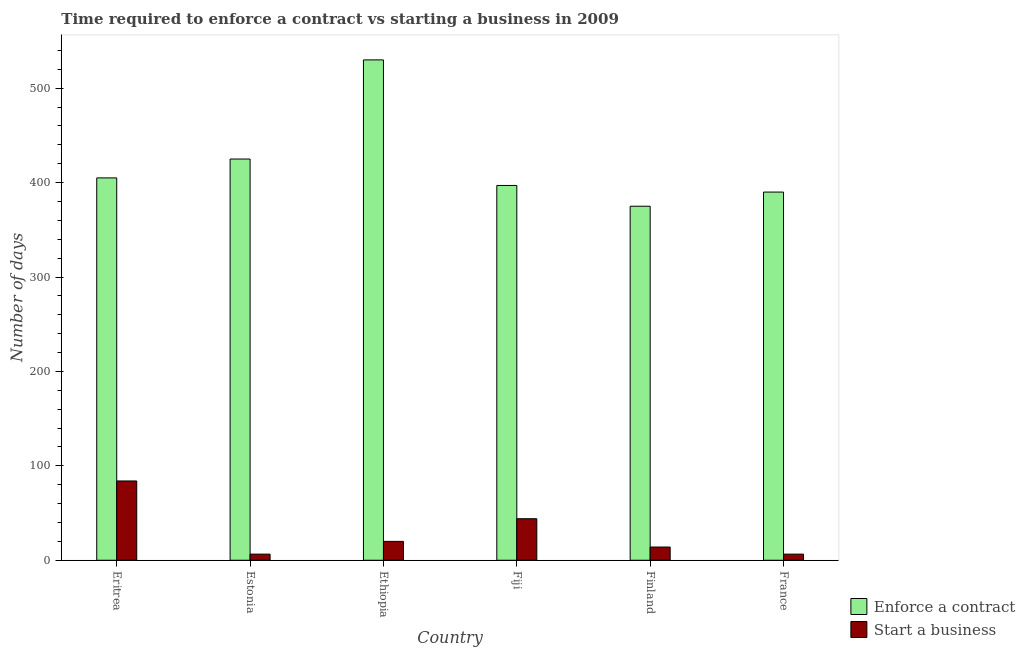How many groups of bars are there?
Provide a short and direct response. 6. Are the number of bars per tick equal to the number of legend labels?
Your answer should be very brief. Yes. Are the number of bars on each tick of the X-axis equal?
Provide a short and direct response. Yes. How many bars are there on the 6th tick from the left?
Your response must be concise. 2. How many bars are there on the 1st tick from the right?
Provide a short and direct response. 2. What is the label of the 4th group of bars from the left?
Give a very brief answer. Fiji. What is the number of days to enforece a contract in Ethiopia?
Provide a short and direct response. 530. Across all countries, what is the maximum number of days to enforece a contract?
Offer a terse response. 530. In which country was the number of days to enforece a contract maximum?
Your response must be concise. Ethiopia. In which country was the number of days to start a business minimum?
Offer a terse response. Estonia. What is the total number of days to enforece a contract in the graph?
Your response must be concise. 2522. What is the difference between the number of days to start a business in Fiji and the number of days to enforece a contract in Estonia?
Offer a very short reply. -381. What is the average number of days to enforece a contract per country?
Make the answer very short. 420.33. What is the difference between the number of days to enforece a contract and number of days to start a business in Ethiopia?
Your answer should be very brief. 510. In how many countries, is the number of days to start a business greater than 260 days?
Your answer should be compact. 0. What is the ratio of the number of days to enforece a contract in Fiji to that in Finland?
Ensure brevity in your answer.  1.06. Is the difference between the number of days to enforece a contract in Ethiopia and Finland greater than the difference between the number of days to start a business in Ethiopia and Finland?
Provide a succinct answer. Yes. What is the difference between the highest and the second highest number of days to start a business?
Offer a very short reply. 40. What is the difference between the highest and the lowest number of days to enforece a contract?
Ensure brevity in your answer.  155. In how many countries, is the number of days to enforece a contract greater than the average number of days to enforece a contract taken over all countries?
Keep it short and to the point. 2. Is the sum of the number of days to start a business in Eritrea and Estonia greater than the maximum number of days to enforece a contract across all countries?
Offer a very short reply. No. What does the 2nd bar from the left in Fiji represents?
Give a very brief answer. Start a business. What does the 2nd bar from the right in Fiji represents?
Provide a succinct answer. Enforce a contract. How many bars are there?
Ensure brevity in your answer.  12. What is the difference between two consecutive major ticks on the Y-axis?
Keep it short and to the point. 100. Are the values on the major ticks of Y-axis written in scientific E-notation?
Provide a succinct answer. No. Does the graph contain grids?
Provide a succinct answer. No. How many legend labels are there?
Your answer should be very brief. 2. What is the title of the graph?
Keep it short and to the point. Time required to enforce a contract vs starting a business in 2009. What is the label or title of the X-axis?
Give a very brief answer. Country. What is the label or title of the Y-axis?
Offer a very short reply. Number of days. What is the Number of days of Enforce a contract in Eritrea?
Your answer should be very brief. 405. What is the Number of days of Enforce a contract in Estonia?
Offer a terse response. 425. What is the Number of days in Start a business in Estonia?
Keep it short and to the point. 6.5. What is the Number of days in Enforce a contract in Ethiopia?
Provide a succinct answer. 530. What is the Number of days of Enforce a contract in Fiji?
Provide a succinct answer. 397. What is the Number of days in Enforce a contract in Finland?
Ensure brevity in your answer.  375. What is the Number of days of Enforce a contract in France?
Give a very brief answer. 390. What is the Number of days in Start a business in France?
Provide a succinct answer. 6.5. Across all countries, what is the maximum Number of days in Enforce a contract?
Provide a short and direct response. 530. Across all countries, what is the minimum Number of days of Enforce a contract?
Make the answer very short. 375. Across all countries, what is the minimum Number of days in Start a business?
Ensure brevity in your answer.  6.5. What is the total Number of days in Enforce a contract in the graph?
Your answer should be compact. 2522. What is the total Number of days of Start a business in the graph?
Offer a very short reply. 175. What is the difference between the Number of days in Start a business in Eritrea and that in Estonia?
Offer a terse response. 77.5. What is the difference between the Number of days of Enforce a contract in Eritrea and that in Ethiopia?
Your response must be concise. -125. What is the difference between the Number of days of Enforce a contract in Eritrea and that in Fiji?
Make the answer very short. 8. What is the difference between the Number of days in Start a business in Eritrea and that in Fiji?
Offer a terse response. 40. What is the difference between the Number of days in Enforce a contract in Eritrea and that in Finland?
Provide a succinct answer. 30. What is the difference between the Number of days in Enforce a contract in Eritrea and that in France?
Your response must be concise. 15. What is the difference between the Number of days in Start a business in Eritrea and that in France?
Your answer should be compact. 77.5. What is the difference between the Number of days in Enforce a contract in Estonia and that in Ethiopia?
Give a very brief answer. -105. What is the difference between the Number of days in Start a business in Estonia and that in Fiji?
Ensure brevity in your answer.  -37.5. What is the difference between the Number of days of Enforce a contract in Estonia and that in Finland?
Provide a short and direct response. 50. What is the difference between the Number of days of Start a business in Estonia and that in France?
Provide a short and direct response. 0. What is the difference between the Number of days in Enforce a contract in Ethiopia and that in Fiji?
Provide a short and direct response. 133. What is the difference between the Number of days of Start a business in Ethiopia and that in Fiji?
Ensure brevity in your answer.  -24. What is the difference between the Number of days of Enforce a contract in Ethiopia and that in Finland?
Your response must be concise. 155. What is the difference between the Number of days of Enforce a contract in Ethiopia and that in France?
Offer a very short reply. 140. What is the difference between the Number of days in Enforce a contract in Fiji and that in Finland?
Offer a terse response. 22. What is the difference between the Number of days of Start a business in Fiji and that in France?
Ensure brevity in your answer.  37.5. What is the difference between the Number of days of Start a business in Finland and that in France?
Keep it short and to the point. 7.5. What is the difference between the Number of days in Enforce a contract in Eritrea and the Number of days in Start a business in Estonia?
Your answer should be compact. 398.5. What is the difference between the Number of days in Enforce a contract in Eritrea and the Number of days in Start a business in Ethiopia?
Your answer should be compact. 385. What is the difference between the Number of days of Enforce a contract in Eritrea and the Number of days of Start a business in Fiji?
Make the answer very short. 361. What is the difference between the Number of days of Enforce a contract in Eritrea and the Number of days of Start a business in Finland?
Provide a succinct answer. 391. What is the difference between the Number of days of Enforce a contract in Eritrea and the Number of days of Start a business in France?
Provide a short and direct response. 398.5. What is the difference between the Number of days of Enforce a contract in Estonia and the Number of days of Start a business in Ethiopia?
Make the answer very short. 405. What is the difference between the Number of days of Enforce a contract in Estonia and the Number of days of Start a business in Fiji?
Offer a terse response. 381. What is the difference between the Number of days in Enforce a contract in Estonia and the Number of days in Start a business in Finland?
Offer a terse response. 411. What is the difference between the Number of days in Enforce a contract in Estonia and the Number of days in Start a business in France?
Ensure brevity in your answer.  418.5. What is the difference between the Number of days of Enforce a contract in Ethiopia and the Number of days of Start a business in Fiji?
Your response must be concise. 486. What is the difference between the Number of days of Enforce a contract in Ethiopia and the Number of days of Start a business in Finland?
Your answer should be compact. 516. What is the difference between the Number of days of Enforce a contract in Ethiopia and the Number of days of Start a business in France?
Keep it short and to the point. 523.5. What is the difference between the Number of days in Enforce a contract in Fiji and the Number of days in Start a business in Finland?
Make the answer very short. 383. What is the difference between the Number of days in Enforce a contract in Fiji and the Number of days in Start a business in France?
Keep it short and to the point. 390.5. What is the difference between the Number of days in Enforce a contract in Finland and the Number of days in Start a business in France?
Provide a short and direct response. 368.5. What is the average Number of days of Enforce a contract per country?
Your answer should be very brief. 420.33. What is the average Number of days of Start a business per country?
Offer a terse response. 29.17. What is the difference between the Number of days in Enforce a contract and Number of days in Start a business in Eritrea?
Your response must be concise. 321. What is the difference between the Number of days of Enforce a contract and Number of days of Start a business in Estonia?
Provide a short and direct response. 418.5. What is the difference between the Number of days of Enforce a contract and Number of days of Start a business in Ethiopia?
Your answer should be very brief. 510. What is the difference between the Number of days in Enforce a contract and Number of days in Start a business in Fiji?
Provide a succinct answer. 353. What is the difference between the Number of days in Enforce a contract and Number of days in Start a business in Finland?
Keep it short and to the point. 361. What is the difference between the Number of days of Enforce a contract and Number of days of Start a business in France?
Provide a short and direct response. 383.5. What is the ratio of the Number of days of Enforce a contract in Eritrea to that in Estonia?
Make the answer very short. 0.95. What is the ratio of the Number of days in Start a business in Eritrea to that in Estonia?
Keep it short and to the point. 12.92. What is the ratio of the Number of days in Enforce a contract in Eritrea to that in Ethiopia?
Offer a terse response. 0.76. What is the ratio of the Number of days in Start a business in Eritrea to that in Ethiopia?
Give a very brief answer. 4.2. What is the ratio of the Number of days of Enforce a contract in Eritrea to that in Fiji?
Ensure brevity in your answer.  1.02. What is the ratio of the Number of days in Start a business in Eritrea to that in Fiji?
Offer a terse response. 1.91. What is the ratio of the Number of days in Enforce a contract in Eritrea to that in Finland?
Provide a succinct answer. 1.08. What is the ratio of the Number of days in Start a business in Eritrea to that in Finland?
Ensure brevity in your answer.  6. What is the ratio of the Number of days in Enforce a contract in Eritrea to that in France?
Provide a succinct answer. 1.04. What is the ratio of the Number of days of Start a business in Eritrea to that in France?
Provide a short and direct response. 12.92. What is the ratio of the Number of days of Enforce a contract in Estonia to that in Ethiopia?
Your answer should be compact. 0.8. What is the ratio of the Number of days in Start a business in Estonia to that in Ethiopia?
Give a very brief answer. 0.33. What is the ratio of the Number of days in Enforce a contract in Estonia to that in Fiji?
Your answer should be very brief. 1.07. What is the ratio of the Number of days in Start a business in Estonia to that in Fiji?
Your response must be concise. 0.15. What is the ratio of the Number of days in Enforce a contract in Estonia to that in Finland?
Offer a terse response. 1.13. What is the ratio of the Number of days in Start a business in Estonia to that in Finland?
Make the answer very short. 0.46. What is the ratio of the Number of days in Enforce a contract in Estonia to that in France?
Your response must be concise. 1.09. What is the ratio of the Number of days in Start a business in Estonia to that in France?
Provide a short and direct response. 1. What is the ratio of the Number of days in Enforce a contract in Ethiopia to that in Fiji?
Provide a short and direct response. 1.33. What is the ratio of the Number of days in Start a business in Ethiopia to that in Fiji?
Your answer should be compact. 0.45. What is the ratio of the Number of days in Enforce a contract in Ethiopia to that in Finland?
Offer a very short reply. 1.41. What is the ratio of the Number of days of Start a business in Ethiopia to that in Finland?
Provide a succinct answer. 1.43. What is the ratio of the Number of days of Enforce a contract in Ethiopia to that in France?
Provide a short and direct response. 1.36. What is the ratio of the Number of days of Start a business in Ethiopia to that in France?
Provide a succinct answer. 3.08. What is the ratio of the Number of days of Enforce a contract in Fiji to that in Finland?
Provide a short and direct response. 1.06. What is the ratio of the Number of days in Start a business in Fiji to that in Finland?
Provide a succinct answer. 3.14. What is the ratio of the Number of days of Enforce a contract in Fiji to that in France?
Ensure brevity in your answer.  1.02. What is the ratio of the Number of days in Start a business in Fiji to that in France?
Provide a short and direct response. 6.77. What is the ratio of the Number of days in Enforce a contract in Finland to that in France?
Keep it short and to the point. 0.96. What is the ratio of the Number of days of Start a business in Finland to that in France?
Provide a short and direct response. 2.15. What is the difference between the highest and the second highest Number of days in Enforce a contract?
Provide a short and direct response. 105. What is the difference between the highest and the lowest Number of days of Enforce a contract?
Your response must be concise. 155. What is the difference between the highest and the lowest Number of days in Start a business?
Make the answer very short. 77.5. 